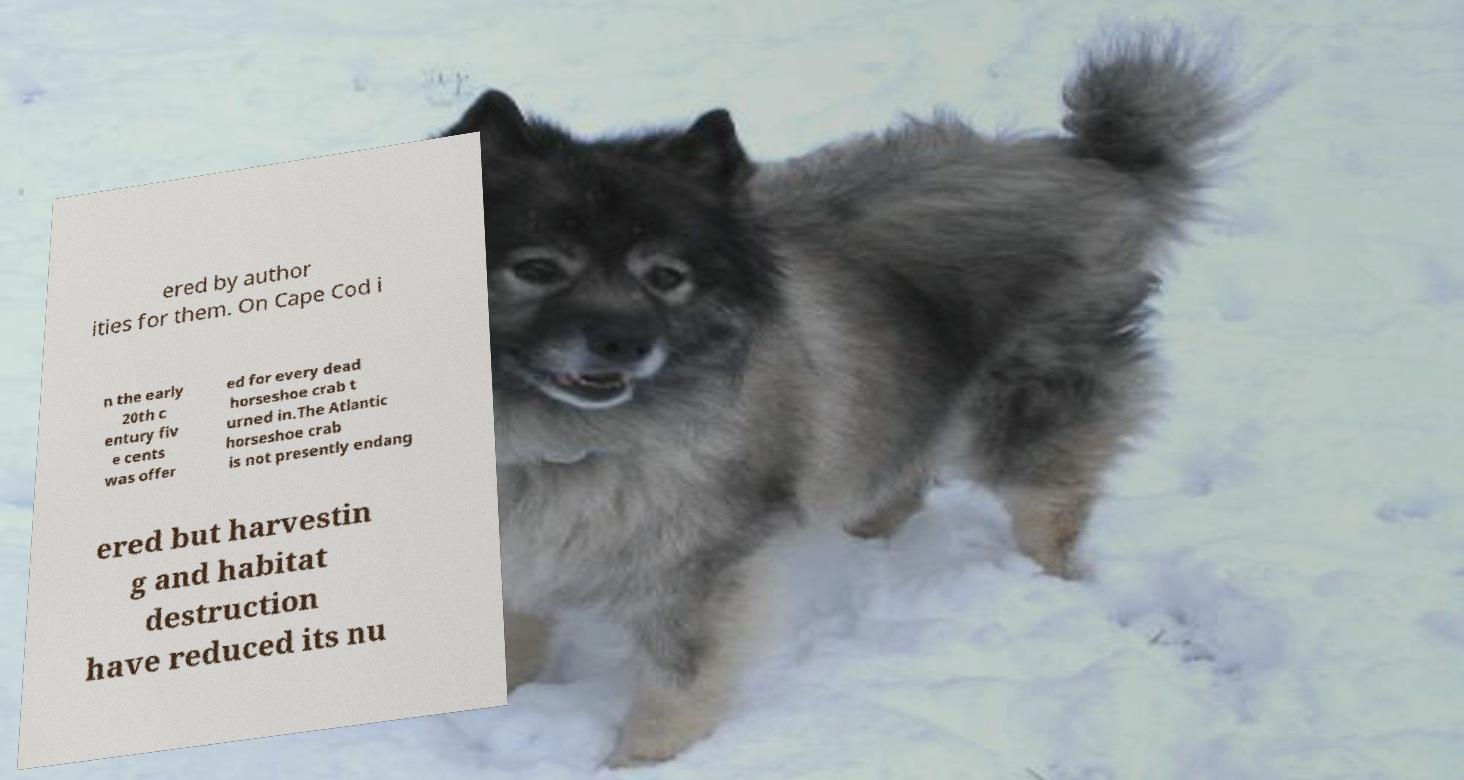What messages or text are displayed in this image? I need them in a readable, typed format. ered by author ities for them. On Cape Cod i n the early 20th c entury fiv e cents was offer ed for every dead horseshoe crab t urned in.The Atlantic horseshoe crab is not presently endang ered but harvestin g and habitat destruction have reduced its nu 